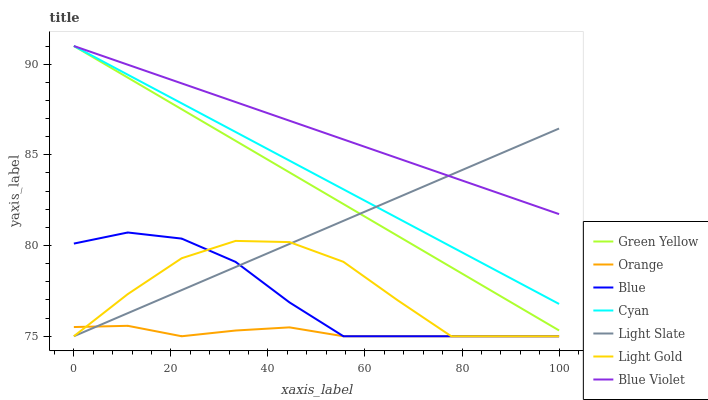Does Orange have the minimum area under the curve?
Answer yes or no. Yes. Does Blue Violet have the maximum area under the curve?
Answer yes or no. Yes. Does Light Slate have the minimum area under the curve?
Answer yes or no. No. Does Light Slate have the maximum area under the curve?
Answer yes or no. No. Is Light Slate the smoothest?
Answer yes or no. Yes. Is Light Gold the roughest?
Answer yes or no. Yes. Is Orange the smoothest?
Answer yes or no. No. Is Orange the roughest?
Answer yes or no. No. Does Blue have the lowest value?
Answer yes or no. Yes. Does Cyan have the lowest value?
Answer yes or no. No. Does Blue Violet have the highest value?
Answer yes or no. Yes. Does Light Slate have the highest value?
Answer yes or no. No. Is Orange less than Green Yellow?
Answer yes or no. Yes. Is Green Yellow greater than Light Gold?
Answer yes or no. Yes. Does Light Slate intersect Blue Violet?
Answer yes or no. Yes. Is Light Slate less than Blue Violet?
Answer yes or no. No. Is Light Slate greater than Blue Violet?
Answer yes or no. No. Does Orange intersect Green Yellow?
Answer yes or no. No. 